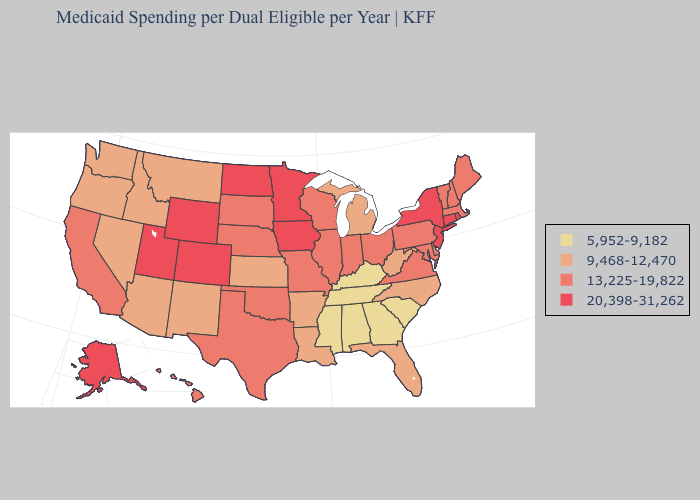What is the lowest value in the USA?
Give a very brief answer. 5,952-9,182. Name the states that have a value in the range 5,952-9,182?
Write a very short answer. Alabama, Georgia, Kentucky, Mississippi, South Carolina, Tennessee. Name the states that have a value in the range 20,398-31,262?
Write a very short answer. Alaska, Colorado, Connecticut, Iowa, Minnesota, New Jersey, New York, North Dakota, Rhode Island, Utah, Wyoming. Does Kentucky have the highest value in the USA?
Keep it brief. No. What is the value of West Virginia?
Keep it brief. 9,468-12,470. What is the lowest value in states that border Delaware?
Answer briefly. 13,225-19,822. Name the states that have a value in the range 9,468-12,470?
Be succinct. Arizona, Arkansas, Florida, Idaho, Kansas, Louisiana, Michigan, Montana, Nevada, New Mexico, North Carolina, Oregon, Washington, West Virginia. What is the value of Utah?
Answer briefly. 20,398-31,262. Does the first symbol in the legend represent the smallest category?
Keep it brief. Yes. What is the value of New Hampshire?
Be succinct. 13,225-19,822. Does Ohio have a lower value than New Mexico?
Write a very short answer. No. What is the value of Utah?
Concise answer only. 20,398-31,262. What is the lowest value in the West?
Be succinct. 9,468-12,470. Is the legend a continuous bar?
Keep it brief. No. What is the value of Indiana?
Short answer required. 13,225-19,822. 